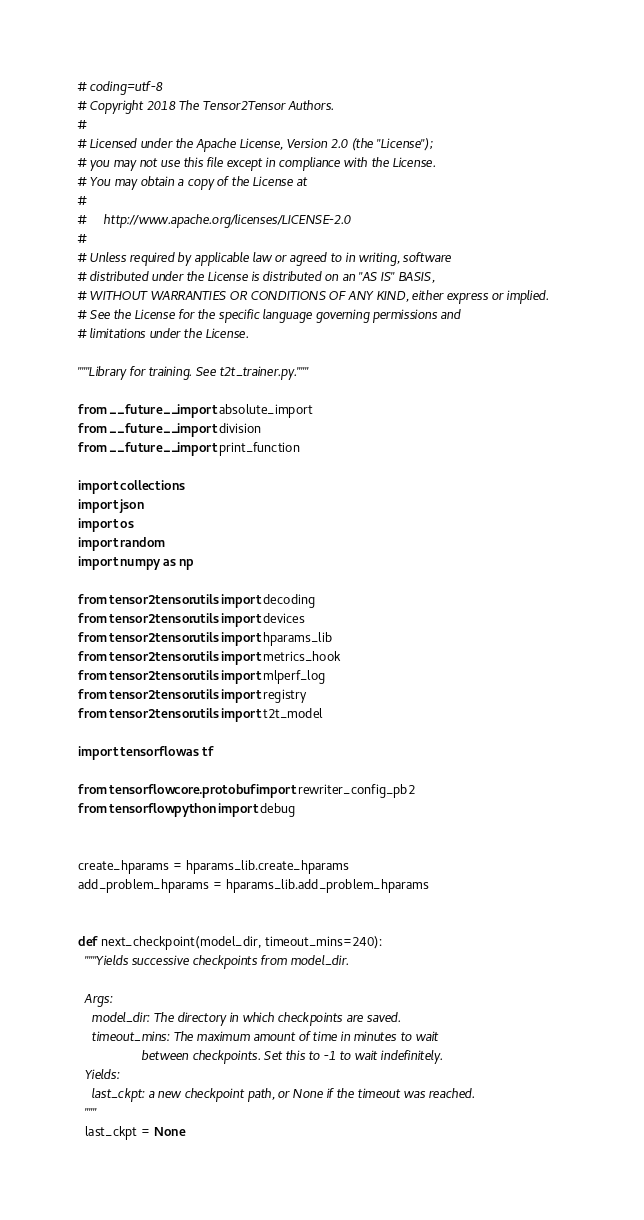Convert code to text. <code><loc_0><loc_0><loc_500><loc_500><_Python_># coding=utf-8
# Copyright 2018 The Tensor2Tensor Authors.
#
# Licensed under the Apache License, Version 2.0 (the "License");
# you may not use this file except in compliance with the License.
# You may obtain a copy of the License at
#
#     http://www.apache.org/licenses/LICENSE-2.0
#
# Unless required by applicable law or agreed to in writing, software
# distributed under the License is distributed on an "AS IS" BASIS,
# WITHOUT WARRANTIES OR CONDITIONS OF ANY KIND, either express or implied.
# See the License for the specific language governing permissions and
# limitations under the License.

"""Library for training. See t2t_trainer.py."""

from __future__ import absolute_import
from __future__ import division
from __future__ import print_function

import collections
import json
import os
import random
import numpy as np

from tensor2tensor.utils import decoding
from tensor2tensor.utils import devices
from tensor2tensor.utils import hparams_lib
from tensor2tensor.utils import metrics_hook
from tensor2tensor.utils import mlperf_log
from tensor2tensor.utils import registry
from tensor2tensor.utils import t2t_model

import tensorflow as tf

from tensorflow.core.protobuf import rewriter_config_pb2
from tensorflow.python import debug


create_hparams = hparams_lib.create_hparams
add_problem_hparams = hparams_lib.add_problem_hparams


def next_checkpoint(model_dir, timeout_mins=240):
  """Yields successive checkpoints from model_dir.

  Args:
    model_dir: The directory in which checkpoints are saved.
    timeout_mins: The maximum amount of time in minutes to wait
                  between checkpoints. Set this to -1 to wait indefinitely.
  Yields:
    last_ckpt: a new checkpoint path, or None if the timeout was reached.
  """
  last_ckpt = None</code> 